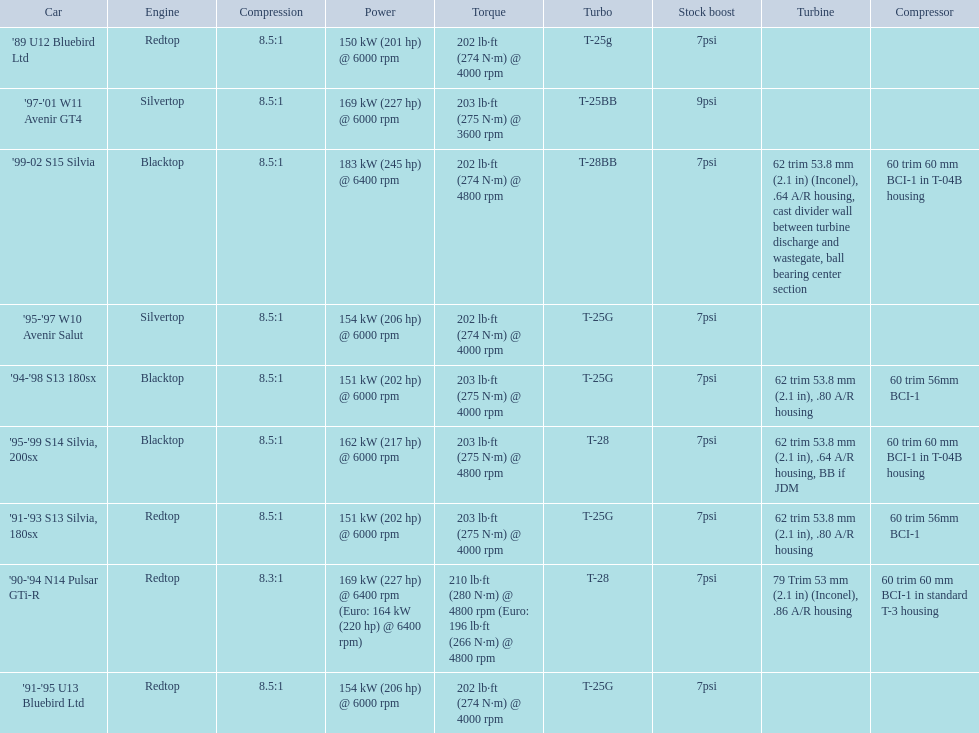Which cars featured blacktop engines? '94-'98 S13 180sx, '95-'99 S14 Silvia, 200sx, '99-02 S15 Silvia. Which of these had t-04b compressor housings? '95-'99 S14 Silvia, 200sx, '99-02 S15 Silvia. Which one of these has the highest horsepower? '99-02 S15 Silvia. Parse the table in full. {'header': ['Car', 'Engine', 'Compression', 'Power', 'Torque', 'Turbo', 'Stock boost', 'Turbine', 'Compressor'], 'rows': [["'89 U12 Bluebird Ltd", 'Redtop', '8.5:1', '150\xa0kW (201\xa0hp) @ 6000 rpm', '202\xa0lb·ft (274\xa0N·m) @ 4000 rpm', 'T-25g', '7psi', '', ''], ["'97-'01 W11 Avenir GT4", 'Silvertop', '8.5:1', '169\xa0kW (227\xa0hp) @ 6000 rpm', '203\xa0lb·ft (275\xa0N·m) @ 3600 rpm', 'T-25BB', '9psi', '', ''], ["'99-02 S15 Silvia", 'Blacktop', '8.5:1', '183\xa0kW (245\xa0hp) @ 6400 rpm', '202\xa0lb·ft (274\xa0N·m) @ 4800 rpm', 'T-28BB', '7psi', '62 trim 53.8\xa0mm (2.1\xa0in) (Inconel), .64 A/R housing, cast divider wall between turbine discharge and wastegate, ball bearing center section', '60 trim 60\xa0mm BCI-1 in T-04B housing'], ["'95-'97 W10 Avenir Salut", 'Silvertop', '8.5:1', '154\xa0kW (206\xa0hp) @ 6000 rpm', '202\xa0lb·ft (274\xa0N·m) @ 4000 rpm', 'T-25G', '7psi', '', ''], ["'94-'98 S13 180sx", 'Blacktop', '8.5:1', '151\xa0kW (202\xa0hp) @ 6000 rpm', '203\xa0lb·ft (275\xa0N·m) @ 4000 rpm', 'T-25G', '7psi', '62 trim 53.8\xa0mm (2.1\xa0in), .80 A/R housing', '60 trim 56mm BCI-1'], ["'95-'99 S14 Silvia, 200sx", 'Blacktop', '8.5:1', '162\xa0kW (217\xa0hp) @ 6000 rpm', '203\xa0lb·ft (275\xa0N·m) @ 4800 rpm', 'T-28', '7psi', '62 trim 53.8\xa0mm (2.1\xa0in), .64 A/R housing, BB if JDM', '60 trim 60\xa0mm BCI-1 in T-04B housing'], ["'91-'93 S13 Silvia, 180sx", 'Redtop', '8.5:1', '151\xa0kW (202\xa0hp) @ 6000 rpm', '203\xa0lb·ft (275\xa0N·m) @ 4000 rpm', 'T-25G', '7psi', '62 trim 53.8\xa0mm (2.1\xa0in), .80 A/R housing', '60 trim 56mm BCI-1'], ["'90-'94 N14 Pulsar GTi-R", 'Redtop', '8.3:1', '169\xa0kW (227\xa0hp) @ 6400 rpm (Euro: 164\xa0kW (220\xa0hp) @ 6400 rpm)', '210\xa0lb·ft (280\xa0N·m) @ 4800 rpm (Euro: 196\xa0lb·ft (266\xa0N·m) @ 4800 rpm', 'T-28', '7psi', '79 Trim 53\xa0mm (2.1\xa0in) (Inconel), .86 A/R housing', '60 trim 60\xa0mm BCI-1 in standard T-3 housing'], ["'91-'95 U13 Bluebird Ltd", 'Redtop', '8.5:1', '154\xa0kW (206\xa0hp) @ 6000 rpm', '202\xa0lb·ft (274\xa0N·m) @ 4000 rpm', 'T-25G', '7psi', '', '']]} 